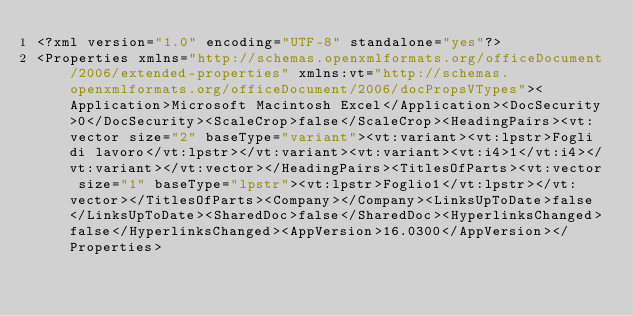Convert code to text. <code><loc_0><loc_0><loc_500><loc_500><_XML_><?xml version="1.0" encoding="UTF-8" standalone="yes"?>
<Properties xmlns="http://schemas.openxmlformats.org/officeDocument/2006/extended-properties" xmlns:vt="http://schemas.openxmlformats.org/officeDocument/2006/docPropsVTypes"><Application>Microsoft Macintosh Excel</Application><DocSecurity>0</DocSecurity><ScaleCrop>false</ScaleCrop><HeadingPairs><vt:vector size="2" baseType="variant"><vt:variant><vt:lpstr>Fogli di lavoro</vt:lpstr></vt:variant><vt:variant><vt:i4>1</vt:i4></vt:variant></vt:vector></HeadingPairs><TitlesOfParts><vt:vector size="1" baseType="lpstr"><vt:lpstr>Foglio1</vt:lpstr></vt:vector></TitlesOfParts><Company></Company><LinksUpToDate>false</LinksUpToDate><SharedDoc>false</SharedDoc><HyperlinksChanged>false</HyperlinksChanged><AppVersion>16.0300</AppVersion></Properties></code> 